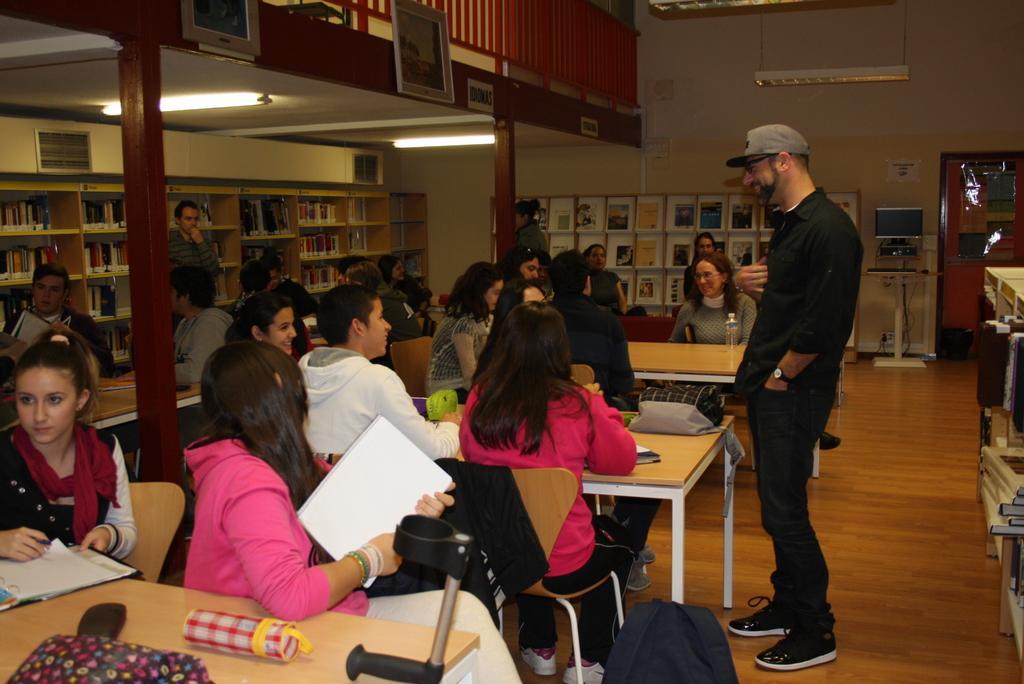Could you give a brief overview of what you see in this image? In this image I see number of people in which most of them are sitting and few of the standing. I can also see there are lot of tables in front of them on which there are few things. In the background I see racks in which there are lot of books and I can also see the lights on the ceiling. 